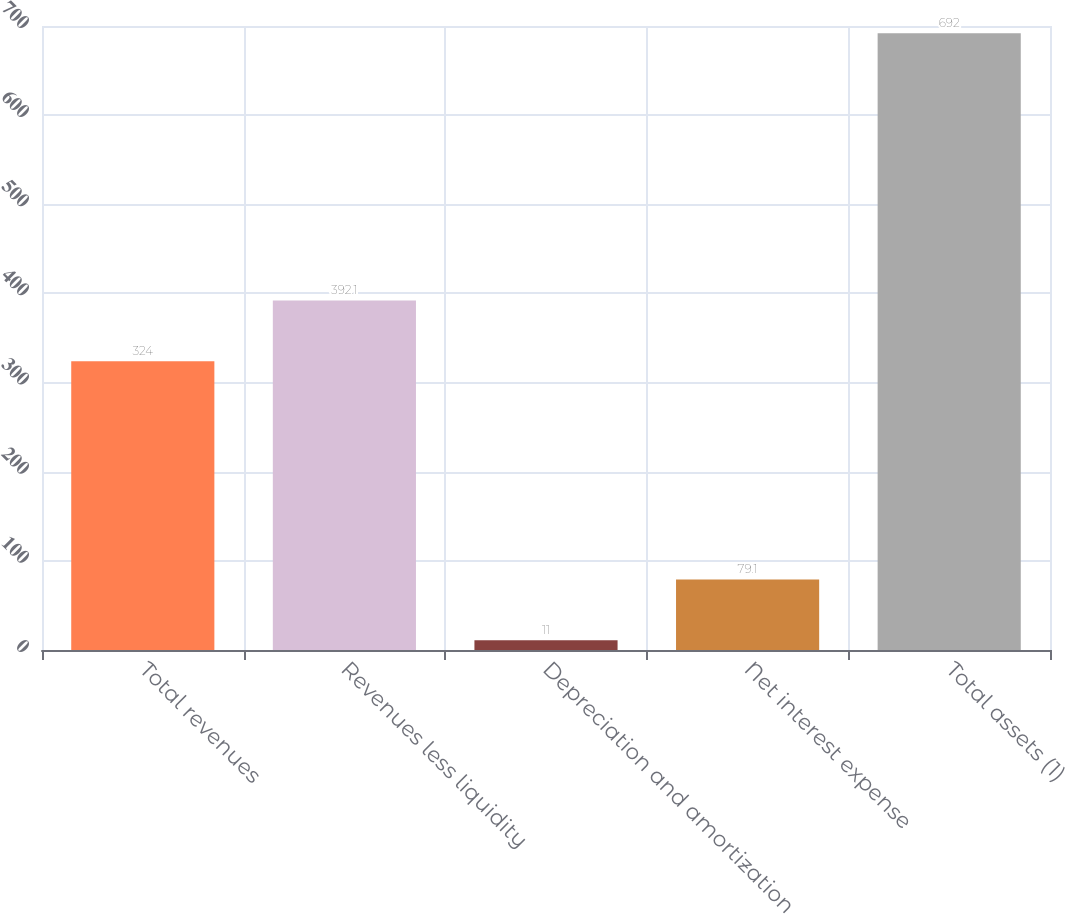Convert chart to OTSL. <chart><loc_0><loc_0><loc_500><loc_500><bar_chart><fcel>Total revenues<fcel>Revenues less liquidity<fcel>Depreciation and amortization<fcel>Net interest expense<fcel>Total assets (1)<nl><fcel>324<fcel>392.1<fcel>11<fcel>79.1<fcel>692<nl></chart> 